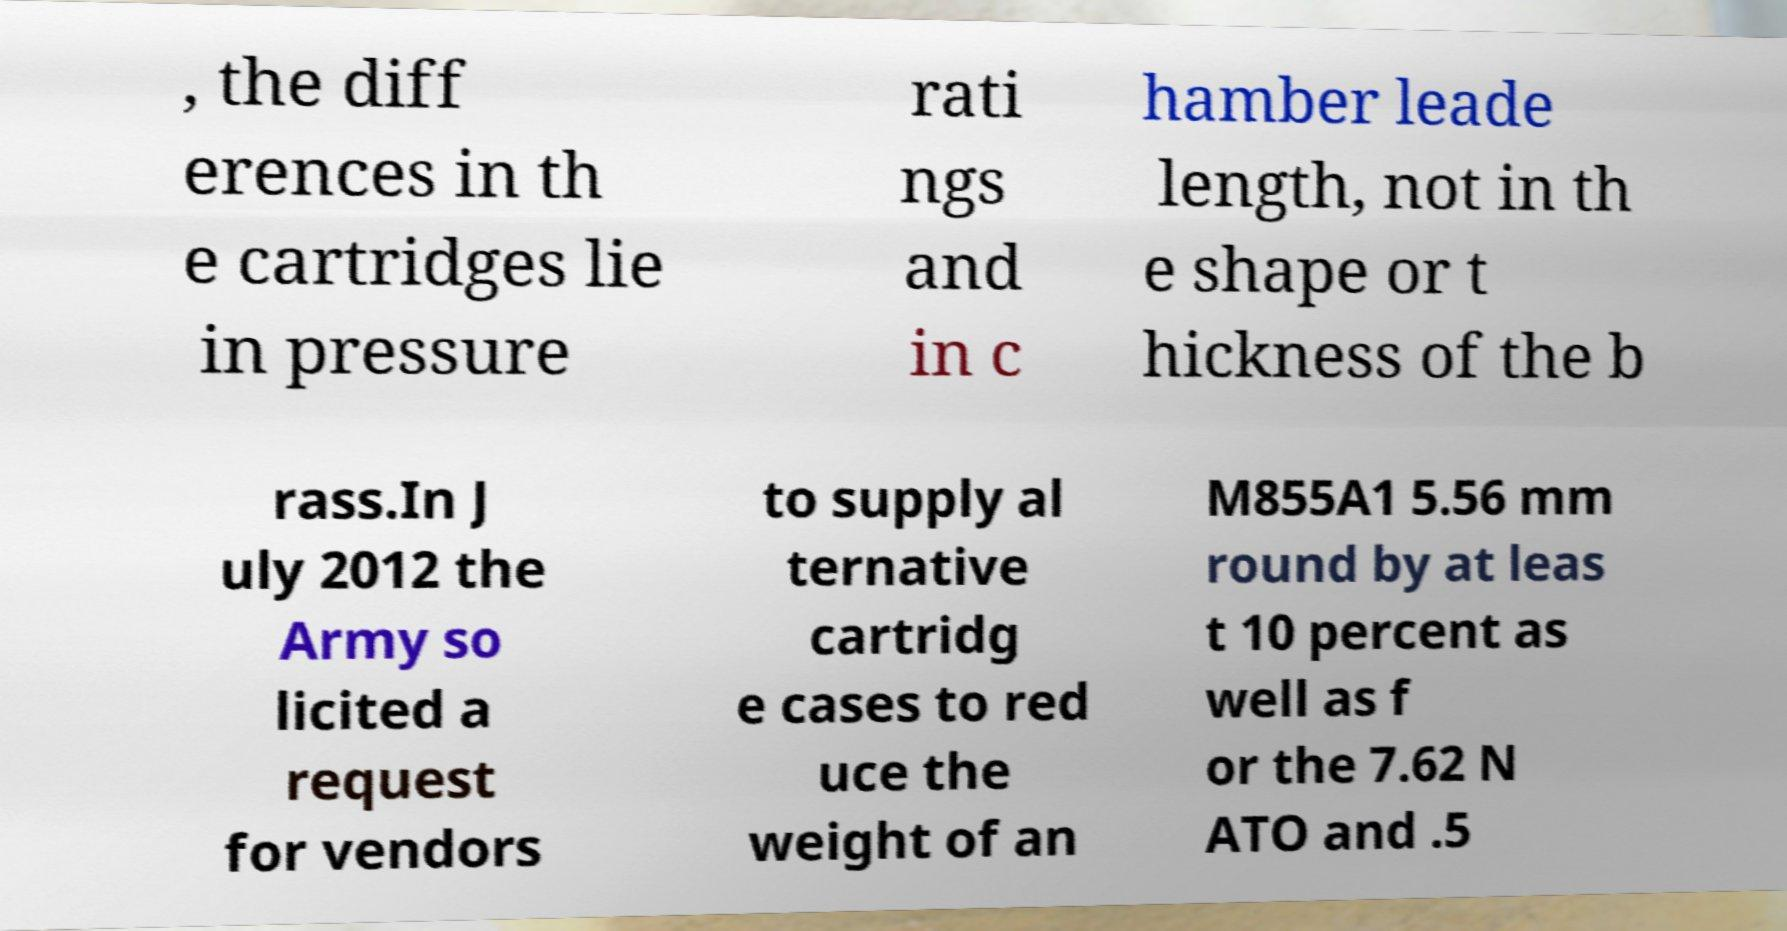Please read and relay the text visible in this image. What does it say? , the diff erences in th e cartridges lie in pressure rati ngs and in c hamber leade length, not in th e shape or t hickness of the b rass.In J uly 2012 the Army so licited a request for vendors to supply al ternative cartridg e cases to red uce the weight of an M855A1 5.56 mm round by at leas t 10 percent as well as f or the 7.62 N ATO and .5 